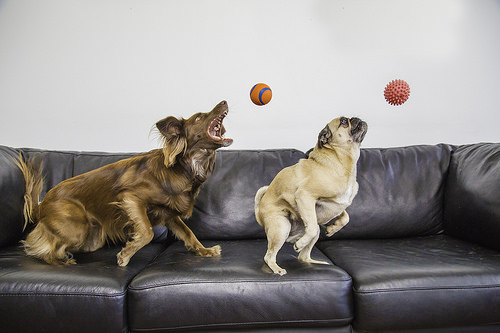<image>
Is there a sofa behind the dog? No. The sofa is not behind the dog. From this viewpoint, the sofa appears to be positioned elsewhere in the scene. Is the dog on the couch? Yes. Looking at the image, I can see the dog is positioned on top of the couch, with the couch providing support. Is there a dog on the sofa? Yes. Looking at the image, I can see the dog is positioned on top of the sofa, with the sofa providing support. Is the brown dog in front of the white dog? No. The brown dog is not in front of the white dog. The spatial positioning shows a different relationship between these objects. 